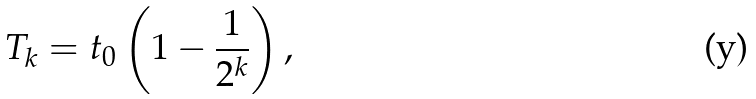Convert formula to latex. <formula><loc_0><loc_0><loc_500><loc_500>T _ { k } = t _ { 0 } \left ( 1 - \frac { 1 } { 2 ^ { k } } \right ) ,</formula> 